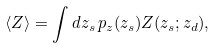Convert formula to latex. <formula><loc_0><loc_0><loc_500><loc_500>\langle Z \rangle = \int d z _ { s } \, p _ { z } ( z _ { s } ) Z ( z _ { s } ; z _ { d } ) ,</formula> 